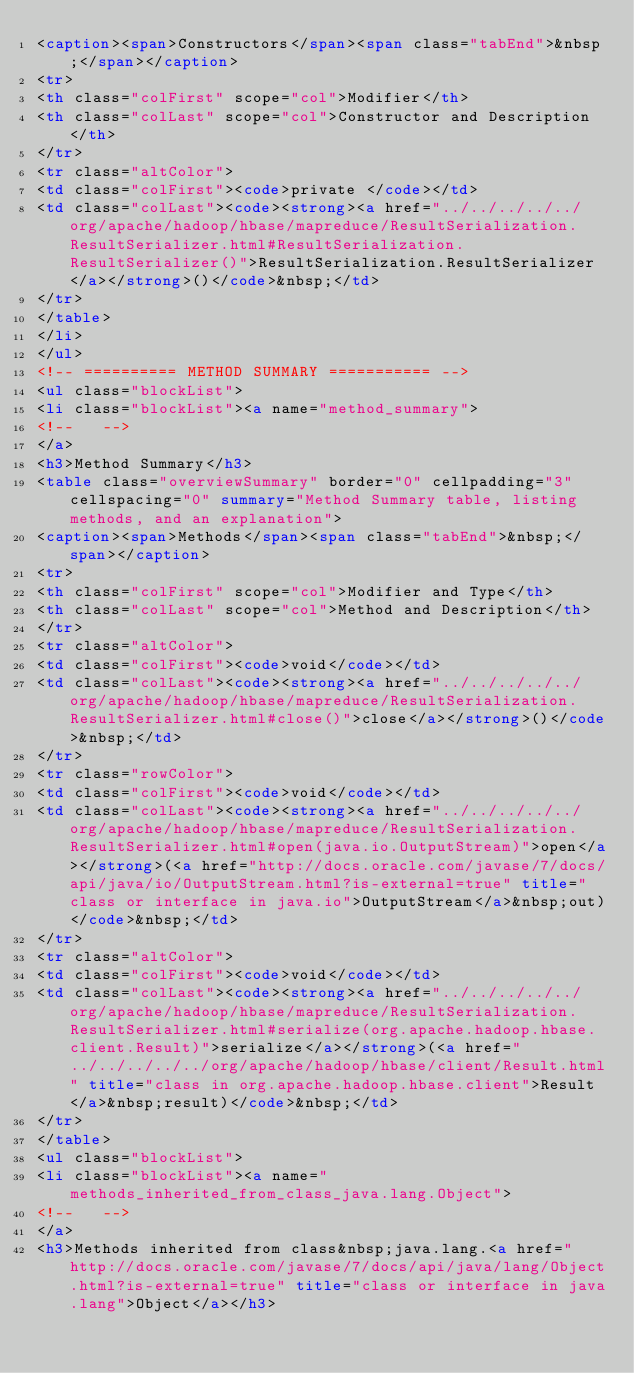Convert code to text. <code><loc_0><loc_0><loc_500><loc_500><_HTML_><caption><span>Constructors</span><span class="tabEnd">&nbsp;</span></caption>
<tr>
<th class="colFirst" scope="col">Modifier</th>
<th class="colLast" scope="col">Constructor and Description</th>
</tr>
<tr class="altColor">
<td class="colFirst"><code>private </code></td>
<td class="colLast"><code><strong><a href="../../../../../org/apache/hadoop/hbase/mapreduce/ResultSerialization.ResultSerializer.html#ResultSerialization.ResultSerializer()">ResultSerialization.ResultSerializer</a></strong>()</code>&nbsp;</td>
</tr>
</table>
</li>
</ul>
<!-- ========== METHOD SUMMARY =========== -->
<ul class="blockList">
<li class="blockList"><a name="method_summary">
<!--   -->
</a>
<h3>Method Summary</h3>
<table class="overviewSummary" border="0" cellpadding="3" cellspacing="0" summary="Method Summary table, listing methods, and an explanation">
<caption><span>Methods</span><span class="tabEnd">&nbsp;</span></caption>
<tr>
<th class="colFirst" scope="col">Modifier and Type</th>
<th class="colLast" scope="col">Method and Description</th>
</tr>
<tr class="altColor">
<td class="colFirst"><code>void</code></td>
<td class="colLast"><code><strong><a href="../../../../../org/apache/hadoop/hbase/mapreduce/ResultSerialization.ResultSerializer.html#close()">close</a></strong>()</code>&nbsp;</td>
</tr>
<tr class="rowColor">
<td class="colFirst"><code>void</code></td>
<td class="colLast"><code><strong><a href="../../../../../org/apache/hadoop/hbase/mapreduce/ResultSerialization.ResultSerializer.html#open(java.io.OutputStream)">open</a></strong>(<a href="http://docs.oracle.com/javase/7/docs/api/java/io/OutputStream.html?is-external=true" title="class or interface in java.io">OutputStream</a>&nbsp;out)</code>&nbsp;</td>
</tr>
<tr class="altColor">
<td class="colFirst"><code>void</code></td>
<td class="colLast"><code><strong><a href="../../../../../org/apache/hadoop/hbase/mapreduce/ResultSerialization.ResultSerializer.html#serialize(org.apache.hadoop.hbase.client.Result)">serialize</a></strong>(<a href="../../../../../org/apache/hadoop/hbase/client/Result.html" title="class in org.apache.hadoop.hbase.client">Result</a>&nbsp;result)</code>&nbsp;</td>
</tr>
</table>
<ul class="blockList">
<li class="blockList"><a name="methods_inherited_from_class_java.lang.Object">
<!--   -->
</a>
<h3>Methods inherited from class&nbsp;java.lang.<a href="http://docs.oracle.com/javase/7/docs/api/java/lang/Object.html?is-external=true" title="class or interface in java.lang">Object</a></h3></code> 